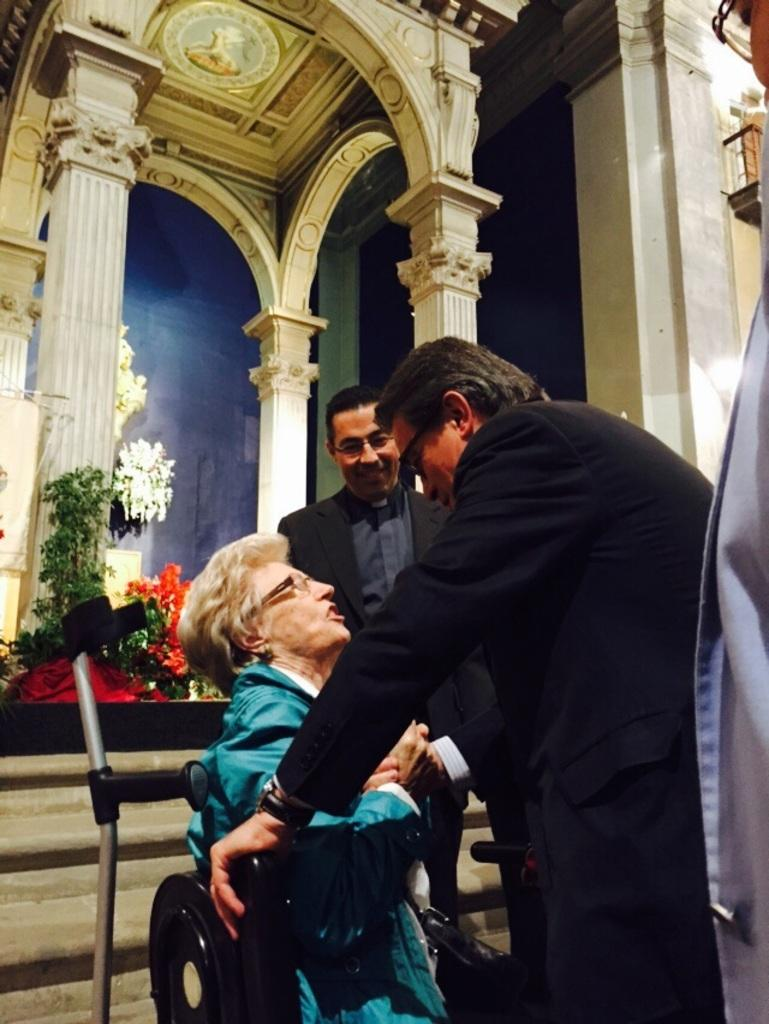What are the people in the image doing? The people in the image are standing. Is there anyone sitting in the image? Yes, there is a person sitting in the image. What can be seen in the background of the image? In the background of the image, there are plants, pillars, and a building. What type of sack is being used to hold the leaf paste in the image? There is no sack or leaf paste present in the image. 